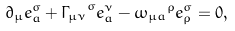<formula> <loc_0><loc_0><loc_500><loc_500>\partial _ { \mu } e ^ { \sigma } _ { a } + { \Gamma _ { \mu \nu } } ^ { \sigma } e ^ { \nu } _ { a } - { \omega _ { \mu a } } ^ { \rho } e _ { \rho } ^ { \sigma } = 0 ,</formula> 